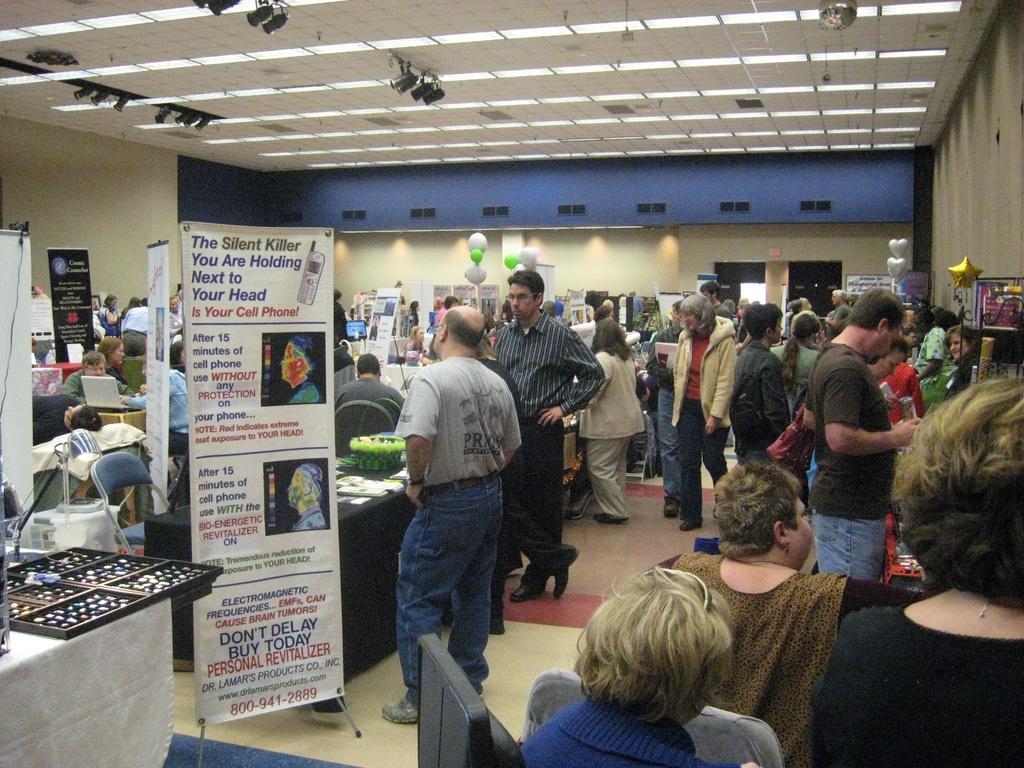In one or two sentences, can you explain what this image depicts? In this image there are group of persons standing and sitting. In the center there is a board with some text and numbers written on it and there are tables and there is an empty chair which is blue in colour and in the background there are persons standing and sitting and there are boards with some text written on it and on the top there are lights and there are objects which are white, golden and green in colour. 